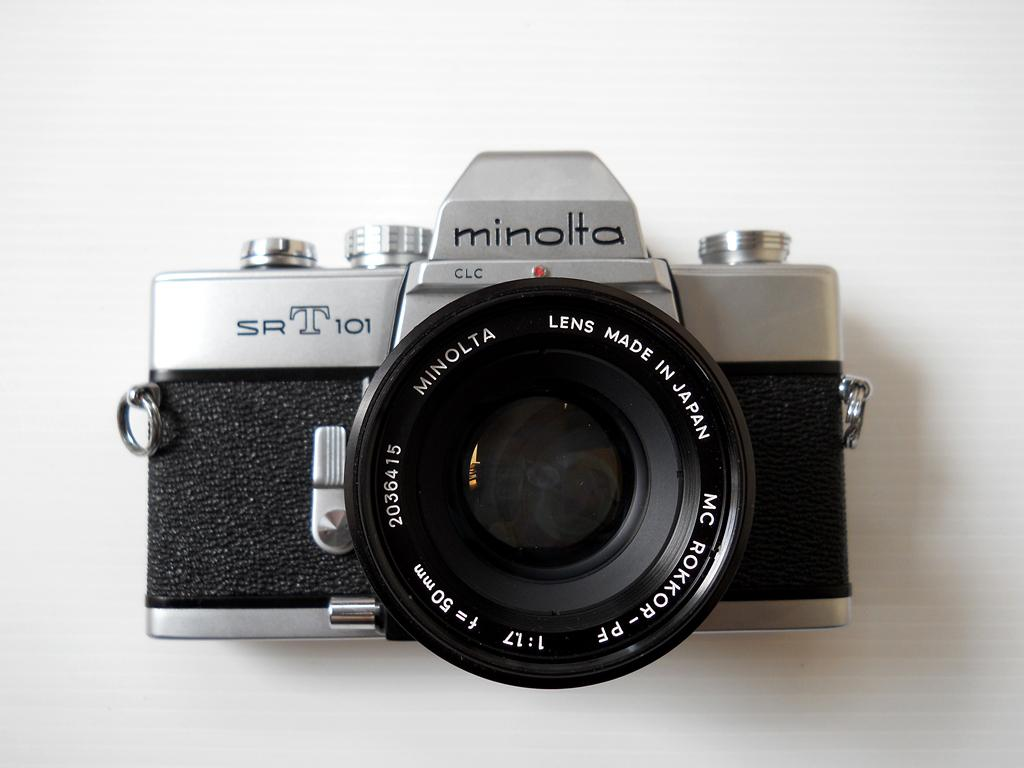<image>
Summarize the visual content of the image. An older style Minolta camera sits on a plain white background. 